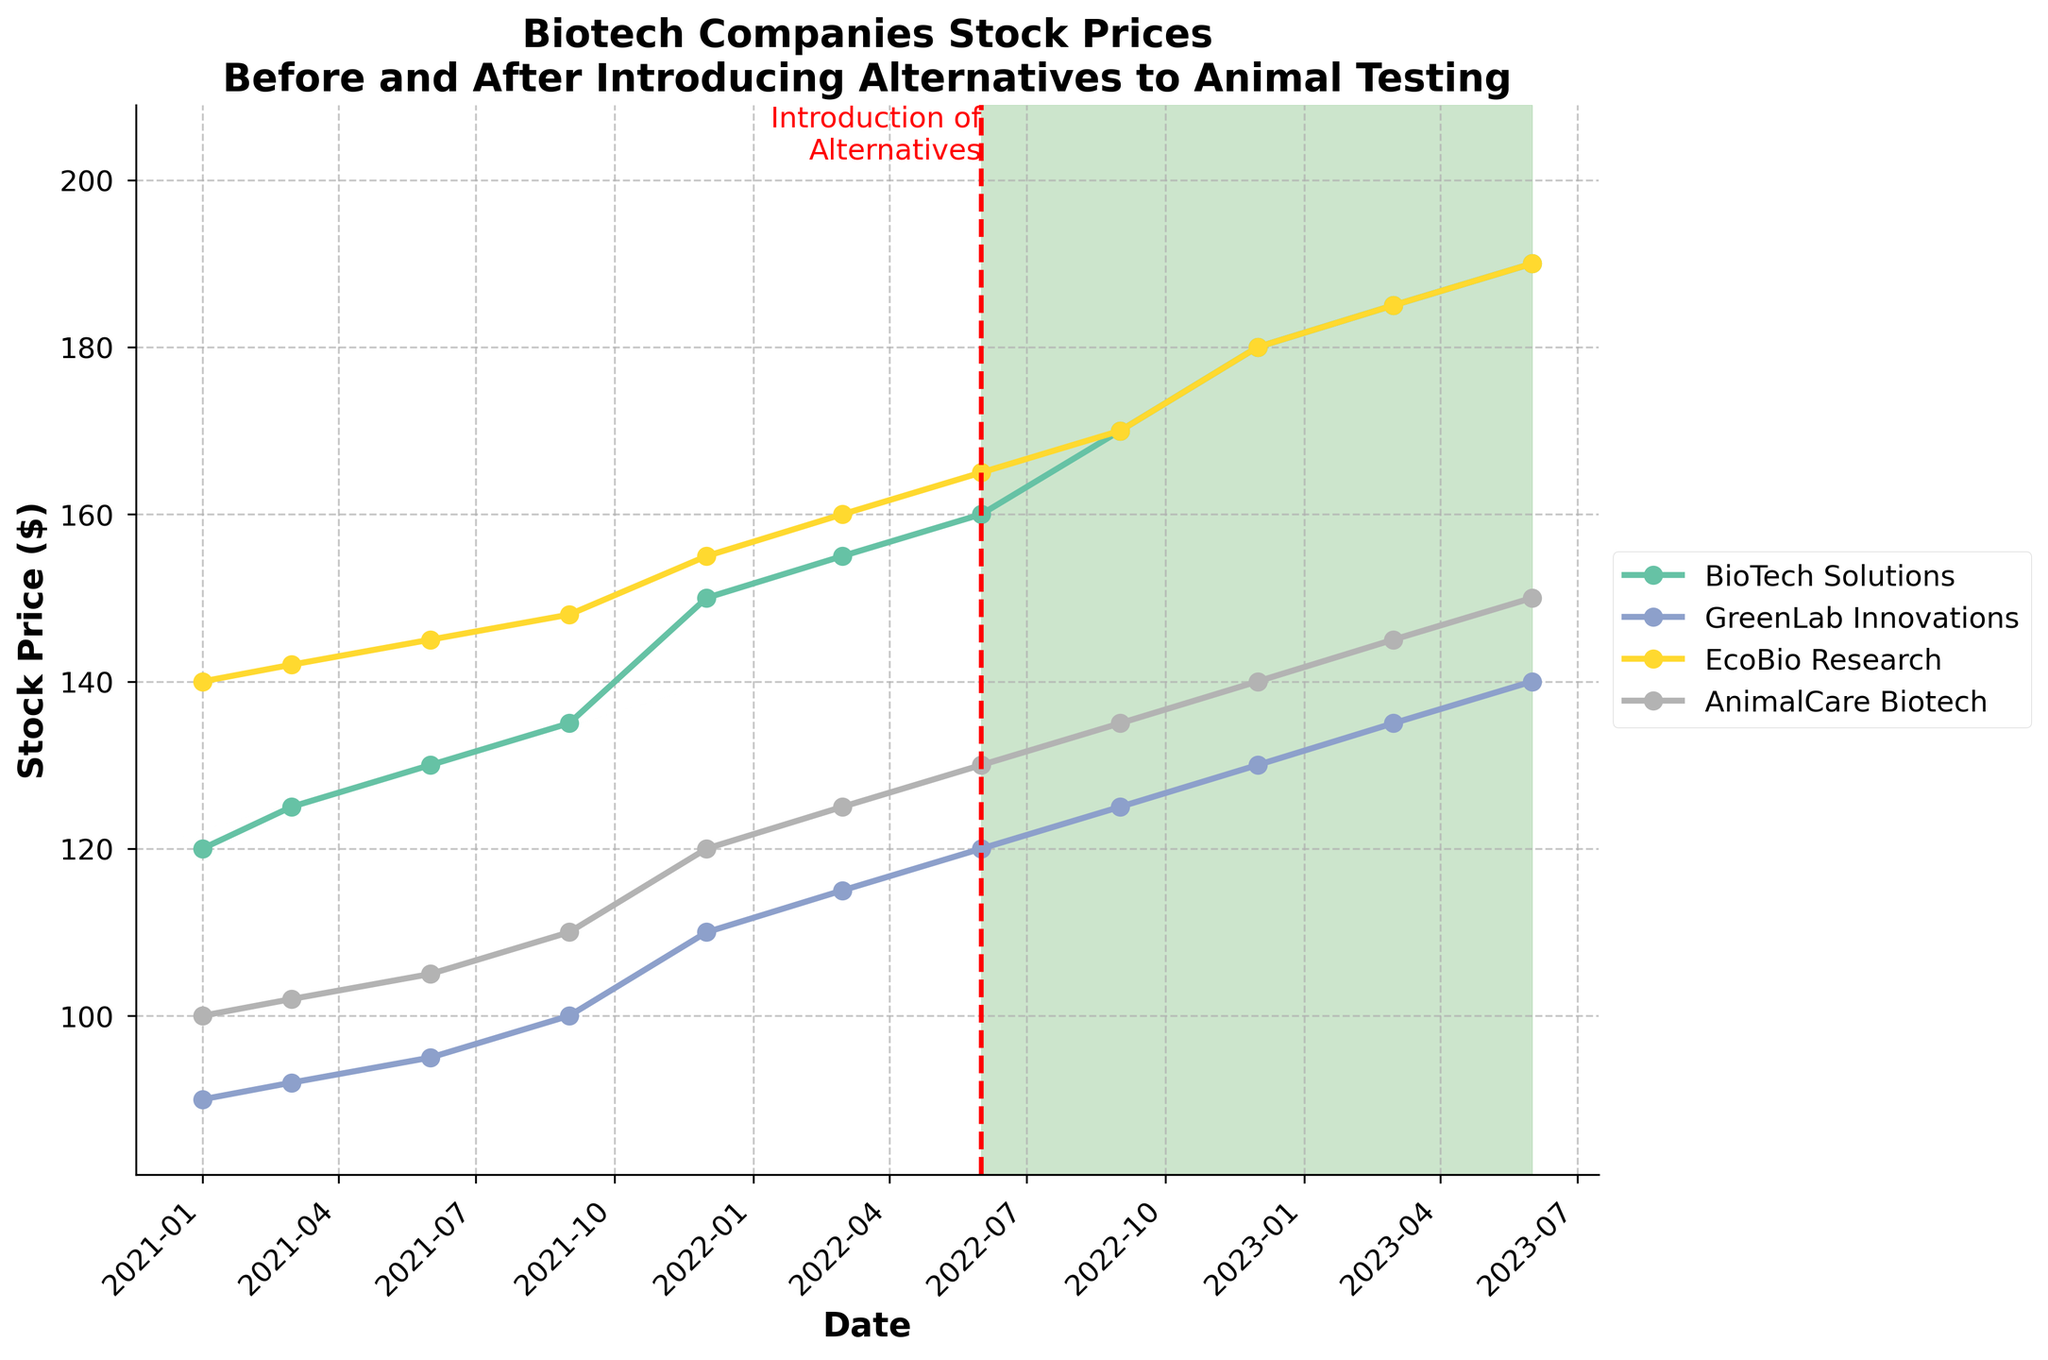What is the title of the figure? The title is located at the top of the figure, and it provides a summary of what the figure represents.
Answer: "Biotech Companies Stock Prices Before and After Introducing Alternatives to Animal Testing" How many companies are represented in the plot? By observing the legend on the right side of the plot, we can count the number of different company names listed.
Answer: 4 Which company has the highest stock price in June 2023? By looking at the data points on the far right of the plot for June 2023, we can compare the stock prices of each company. The highest point corresponds to EcoBio Research.
Answer: EcoBio Research When were alternatives to animal testing introduced? A red vertical dashed line is drawn at a specific point on the x-axis with an annotation that reads "Introduction of Alternatives."
Answer: June 2022 Which company's stock price increased the most from January 2021 to June 2023? To find this, we calculate the difference in stock prices between January 2021 and June 2023 for each company and compare the increases. BioTech Solutions increased from 120 to 190, GreenLab Innovations from 90 to 140, EcoBio Research from 140 to 190, and AnimalCare Biotech from 100 to 150. The biggest increase is 70, which is from BioTech Solutions.
Answer: BioTech Solutions What was the stock price of GreenLab Innovations in December 2021? Locate the data point for GreenLab Innovations in December 2021 on the plot and read the corresponding stock price.
Answer: 110 Compare the stock prices of BioTech Solutions and AnimalCare Biotech in September 2022. Which is higher? Look at the data points for both companies in September 2022 on the plot and compare the values. BioTech Solutions has a stock price of 170, while AnimalCare Biotech has 135.
Answer: BioTech Solutions What is the trend of EcoBio Research's stock price from January 2021 to June 2023? By observing the line representing EcoBio Research, we can notice the general direction. The line shows a consistent upward trend throughout the period.
Answer: Upward In the post-alternative period (after June 2022), which company's stock price showed a slower increase? Compare the slopes of the lines for each company after the introduction of alternatives. GreenLab Innovations has the smallest slope, indicating the slowest increase.
Answer: GreenLab Innovations How did the stock prices behave immediately after the introduction of alternatives to animal testing? By focusing on the segment of the plot right after June 2022, we observe that the stock prices generally continued to increase, with no abrupt declines.
Answer: Increased 